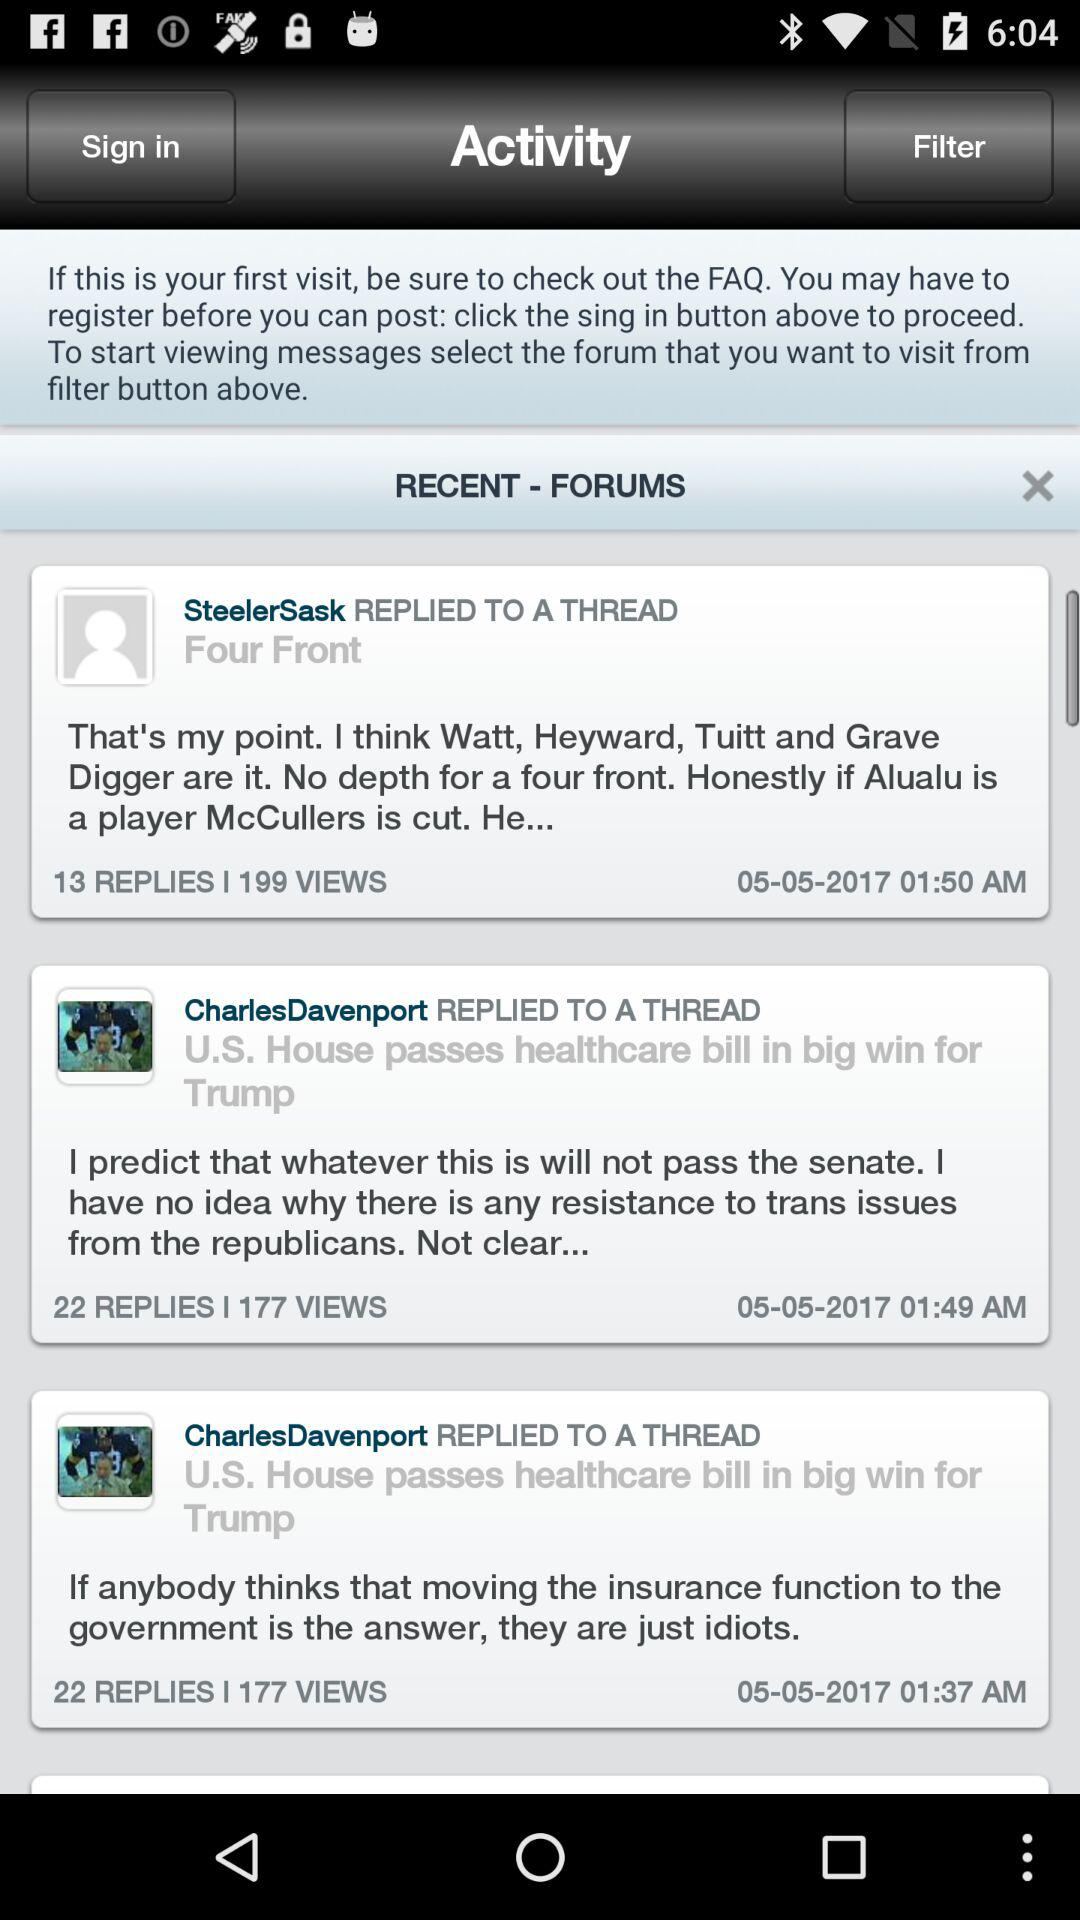How many people viewed Steeler Sask's reply? Steeler Sask's reply was viewed by 199 people. 